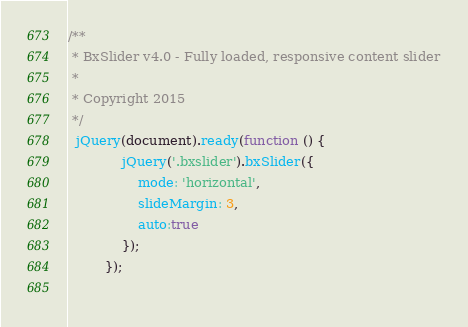<code> <loc_0><loc_0><loc_500><loc_500><_JavaScript_>/**
 * BxSlider v4.0 - Fully loaded, responsive content slider
 *
 * Copyright 2015
 */
  jQuery(document).ready(function () {           
             jQuery('.bxslider').bxSlider({
                 mode: 'horizontal',
                 slideMargin: 3,
                 auto:true
             });             
         });
		 </code> 